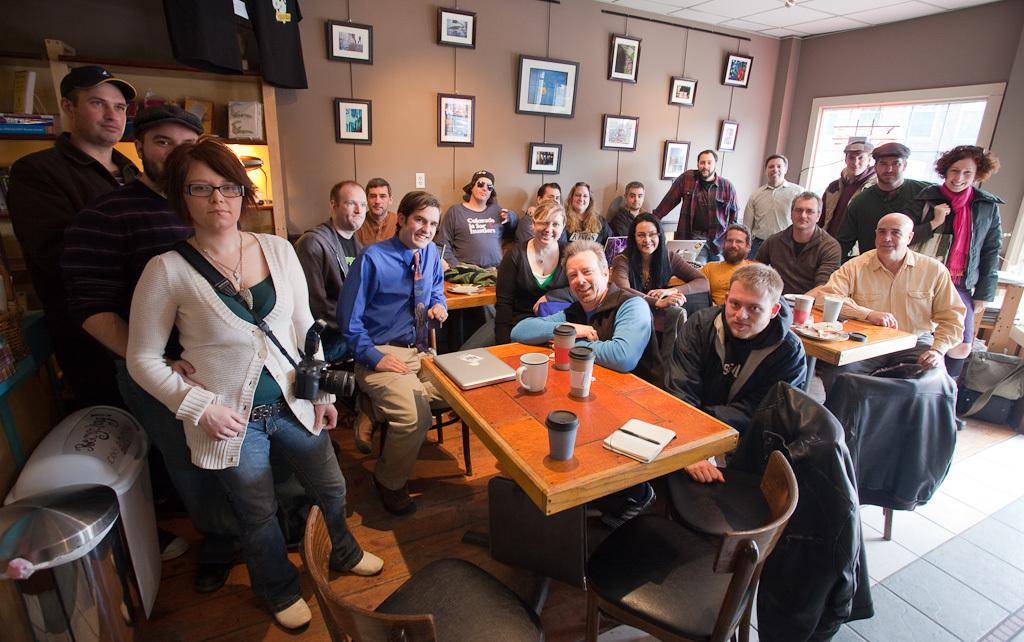What is the woman in the image doing? The woman is standing in the image and holding a camera. What are the people in the image doing? The people are sitting on chairs and smiling. What might the woman be about to do with the camera? The woman might be about to take a picture of the people sitting on chairs. What type of garden can be seen in the image? There is no garden present in the image. 